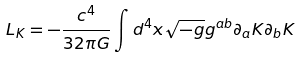<formula> <loc_0><loc_0><loc_500><loc_500>L _ { K } = - \frac { c ^ { 4 } } { 3 2 \pi G } \int { d ^ { 4 } x \sqrt { - g } } g ^ { a b } \partial _ { a } K \partial _ { b } K</formula> 